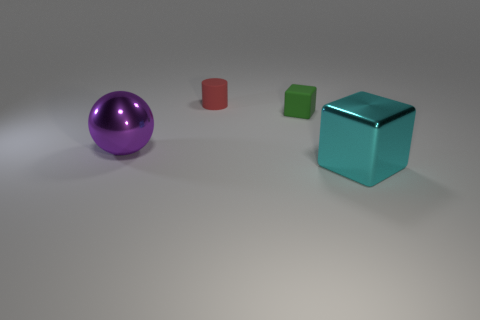Are the tiny thing that is in front of the tiny red rubber object and the small cylinder made of the same material? While it's difficult to determine the exact materials with absolute certainty from an image alone, it is possible to make an educated guess based on the appearance and context clues provided. The small object in front of the red one appears to have a different surface finish and reflects light differently than the cylindrical object, suggesting that they might be made from different materials. However, without physical inspection or additional information, this assessment is speculative. 